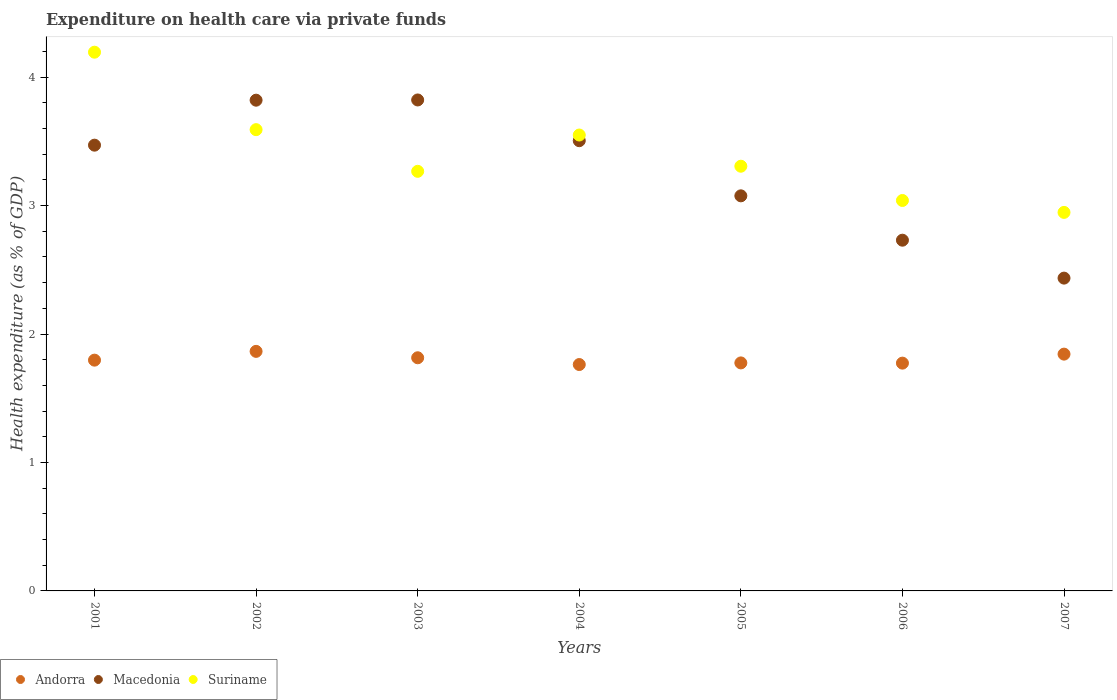What is the expenditure made on health care in Suriname in 2003?
Offer a very short reply. 3.27. Across all years, what is the maximum expenditure made on health care in Macedonia?
Make the answer very short. 3.82. Across all years, what is the minimum expenditure made on health care in Suriname?
Your response must be concise. 2.95. In which year was the expenditure made on health care in Andorra minimum?
Make the answer very short. 2004. What is the total expenditure made on health care in Macedonia in the graph?
Offer a terse response. 22.86. What is the difference between the expenditure made on health care in Suriname in 2001 and that in 2007?
Your response must be concise. 1.25. What is the difference between the expenditure made on health care in Andorra in 2006 and the expenditure made on health care in Suriname in 2004?
Your answer should be very brief. -1.78. What is the average expenditure made on health care in Andorra per year?
Provide a short and direct response. 1.8. In the year 2006, what is the difference between the expenditure made on health care in Suriname and expenditure made on health care in Macedonia?
Ensure brevity in your answer.  0.31. What is the ratio of the expenditure made on health care in Macedonia in 2002 to that in 2006?
Offer a terse response. 1.4. What is the difference between the highest and the second highest expenditure made on health care in Macedonia?
Your answer should be very brief. 0. What is the difference between the highest and the lowest expenditure made on health care in Macedonia?
Offer a very short reply. 1.39. Does the expenditure made on health care in Andorra monotonically increase over the years?
Your answer should be very brief. No. Is the expenditure made on health care in Andorra strictly greater than the expenditure made on health care in Macedonia over the years?
Make the answer very short. No. Is the expenditure made on health care in Suriname strictly less than the expenditure made on health care in Macedonia over the years?
Ensure brevity in your answer.  No. How many dotlines are there?
Offer a very short reply. 3. How many years are there in the graph?
Provide a succinct answer. 7. Are the values on the major ticks of Y-axis written in scientific E-notation?
Offer a very short reply. No. Does the graph contain grids?
Offer a very short reply. No. How many legend labels are there?
Offer a terse response. 3. What is the title of the graph?
Provide a succinct answer. Expenditure on health care via private funds. What is the label or title of the X-axis?
Ensure brevity in your answer.  Years. What is the label or title of the Y-axis?
Your response must be concise. Health expenditure (as % of GDP). What is the Health expenditure (as % of GDP) of Andorra in 2001?
Offer a very short reply. 1.8. What is the Health expenditure (as % of GDP) of Macedonia in 2001?
Provide a short and direct response. 3.47. What is the Health expenditure (as % of GDP) of Suriname in 2001?
Provide a succinct answer. 4.19. What is the Health expenditure (as % of GDP) of Andorra in 2002?
Your answer should be compact. 1.86. What is the Health expenditure (as % of GDP) in Macedonia in 2002?
Provide a succinct answer. 3.82. What is the Health expenditure (as % of GDP) in Suriname in 2002?
Your answer should be very brief. 3.59. What is the Health expenditure (as % of GDP) in Andorra in 2003?
Your answer should be compact. 1.82. What is the Health expenditure (as % of GDP) of Macedonia in 2003?
Offer a very short reply. 3.82. What is the Health expenditure (as % of GDP) of Suriname in 2003?
Offer a very short reply. 3.27. What is the Health expenditure (as % of GDP) in Andorra in 2004?
Ensure brevity in your answer.  1.76. What is the Health expenditure (as % of GDP) in Macedonia in 2004?
Ensure brevity in your answer.  3.5. What is the Health expenditure (as % of GDP) in Suriname in 2004?
Your answer should be compact. 3.55. What is the Health expenditure (as % of GDP) of Andorra in 2005?
Ensure brevity in your answer.  1.77. What is the Health expenditure (as % of GDP) of Macedonia in 2005?
Your response must be concise. 3.08. What is the Health expenditure (as % of GDP) in Suriname in 2005?
Your response must be concise. 3.31. What is the Health expenditure (as % of GDP) in Andorra in 2006?
Your answer should be very brief. 1.77. What is the Health expenditure (as % of GDP) of Macedonia in 2006?
Provide a succinct answer. 2.73. What is the Health expenditure (as % of GDP) of Suriname in 2006?
Provide a short and direct response. 3.04. What is the Health expenditure (as % of GDP) in Andorra in 2007?
Provide a short and direct response. 1.84. What is the Health expenditure (as % of GDP) of Macedonia in 2007?
Your response must be concise. 2.44. What is the Health expenditure (as % of GDP) of Suriname in 2007?
Provide a short and direct response. 2.95. Across all years, what is the maximum Health expenditure (as % of GDP) of Andorra?
Give a very brief answer. 1.86. Across all years, what is the maximum Health expenditure (as % of GDP) of Macedonia?
Keep it short and to the point. 3.82. Across all years, what is the maximum Health expenditure (as % of GDP) in Suriname?
Keep it short and to the point. 4.19. Across all years, what is the minimum Health expenditure (as % of GDP) of Andorra?
Provide a short and direct response. 1.76. Across all years, what is the minimum Health expenditure (as % of GDP) in Macedonia?
Provide a short and direct response. 2.44. Across all years, what is the minimum Health expenditure (as % of GDP) of Suriname?
Your answer should be very brief. 2.95. What is the total Health expenditure (as % of GDP) in Andorra in the graph?
Your answer should be compact. 12.63. What is the total Health expenditure (as % of GDP) of Macedonia in the graph?
Offer a very short reply. 22.86. What is the total Health expenditure (as % of GDP) in Suriname in the graph?
Your answer should be compact. 23.89. What is the difference between the Health expenditure (as % of GDP) in Andorra in 2001 and that in 2002?
Your answer should be very brief. -0.07. What is the difference between the Health expenditure (as % of GDP) of Macedonia in 2001 and that in 2002?
Offer a terse response. -0.35. What is the difference between the Health expenditure (as % of GDP) in Suriname in 2001 and that in 2002?
Give a very brief answer. 0.6. What is the difference between the Health expenditure (as % of GDP) of Andorra in 2001 and that in 2003?
Make the answer very short. -0.02. What is the difference between the Health expenditure (as % of GDP) of Macedonia in 2001 and that in 2003?
Your response must be concise. -0.35. What is the difference between the Health expenditure (as % of GDP) in Suriname in 2001 and that in 2003?
Ensure brevity in your answer.  0.93. What is the difference between the Health expenditure (as % of GDP) in Andorra in 2001 and that in 2004?
Your answer should be very brief. 0.03. What is the difference between the Health expenditure (as % of GDP) of Macedonia in 2001 and that in 2004?
Give a very brief answer. -0.03. What is the difference between the Health expenditure (as % of GDP) in Suriname in 2001 and that in 2004?
Your answer should be compact. 0.64. What is the difference between the Health expenditure (as % of GDP) of Andorra in 2001 and that in 2005?
Ensure brevity in your answer.  0.02. What is the difference between the Health expenditure (as % of GDP) in Macedonia in 2001 and that in 2005?
Make the answer very short. 0.39. What is the difference between the Health expenditure (as % of GDP) of Suriname in 2001 and that in 2005?
Offer a very short reply. 0.89. What is the difference between the Health expenditure (as % of GDP) of Andorra in 2001 and that in 2006?
Offer a terse response. 0.02. What is the difference between the Health expenditure (as % of GDP) of Macedonia in 2001 and that in 2006?
Your answer should be very brief. 0.74. What is the difference between the Health expenditure (as % of GDP) of Suriname in 2001 and that in 2006?
Your response must be concise. 1.15. What is the difference between the Health expenditure (as % of GDP) in Andorra in 2001 and that in 2007?
Keep it short and to the point. -0.05. What is the difference between the Health expenditure (as % of GDP) of Macedonia in 2001 and that in 2007?
Your answer should be very brief. 1.03. What is the difference between the Health expenditure (as % of GDP) of Suriname in 2001 and that in 2007?
Your response must be concise. 1.25. What is the difference between the Health expenditure (as % of GDP) of Andorra in 2002 and that in 2003?
Provide a short and direct response. 0.05. What is the difference between the Health expenditure (as % of GDP) of Macedonia in 2002 and that in 2003?
Your answer should be very brief. -0. What is the difference between the Health expenditure (as % of GDP) in Suriname in 2002 and that in 2003?
Your response must be concise. 0.32. What is the difference between the Health expenditure (as % of GDP) in Andorra in 2002 and that in 2004?
Provide a short and direct response. 0.1. What is the difference between the Health expenditure (as % of GDP) of Macedonia in 2002 and that in 2004?
Offer a very short reply. 0.32. What is the difference between the Health expenditure (as % of GDP) in Suriname in 2002 and that in 2004?
Give a very brief answer. 0.04. What is the difference between the Health expenditure (as % of GDP) of Andorra in 2002 and that in 2005?
Ensure brevity in your answer.  0.09. What is the difference between the Health expenditure (as % of GDP) of Macedonia in 2002 and that in 2005?
Offer a very short reply. 0.74. What is the difference between the Health expenditure (as % of GDP) in Suriname in 2002 and that in 2005?
Give a very brief answer. 0.28. What is the difference between the Health expenditure (as % of GDP) in Andorra in 2002 and that in 2006?
Your response must be concise. 0.09. What is the difference between the Health expenditure (as % of GDP) in Macedonia in 2002 and that in 2006?
Keep it short and to the point. 1.09. What is the difference between the Health expenditure (as % of GDP) in Suriname in 2002 and that in 2006?
Give a very brief answer. 0.55. What is the difference between the Health expenditure (as % of GDP) of Andorra in 2002 and that in 2007?
Give a very brief answer. 0.02. What is the difference between the Health expenditure (as % of GDP) of Macedonia in 2002 and that in 2007?
Make the answer very short. 1.39. What is the difference between the Health expenditure (as % of GDP) in Suriname in 2002 and that in 2007?
Your answer should be compact. 0.64. What is the difference between the Health expenditure (as % of GDP) in Andorra in 2003 and that in 2004?
Your answer should be very brief. 0.05. What is the difference between the Health expenditure (as % of GDP) of Macedonia in 2003 and that in 2004?
Offer a very short reply. 0.32. What is the difference between the Health expenditure (as % of GDP) of Suriname in 2003 and that in 2004?
Make the answer very short. -0.28. What is the difference between the Health expenditure (as % of GDP) in Macedonia in 2003 and that in 2005?
Offer a very short reply. 0.75. What is the difference between the Health expenditure (as % of GDP) in Suriname in 2003 and that in 2005?
Offer a terse response. -0.04. What is the difference between the Health expenditure (as % of GDP) in Andorra in 2003 and that in 2006?
Ensure brevity in your answer.  0.04. What is the difference between the Health expenditure (as % of GDP) in Macedonia in 2003 and that in 2006?
Make the answer very short. 1.09. What is the difference between the Health expenditure (as % of GDP) of Suriname in 2003 and that in 2006?
Ensure brevity in your answer.  0.23. What is the difference between the Health expenditure (as % of GDP) in Andorra in 2003 and that in 2007?
Your answer should be very brief. -0.03. What is the difference between the Health expenditure (as % of GDP) in Macedonia in 2003 and that in 2007?
Keep it short and to the point. 1.39. What is the difference between the Health expenditure (as % of GDP) of Suriname in 2003 and that in 2007?
Provide a short and direct response. 0.32. What is the difference between the Health expenditure (as % of GDP) in Andorra in 2004 and that in 2005?
Provide a succinct answer. -0.01. What is the difference between the Health expenditure (as % of GDP) of Macedonia in 2004 and that in 2005?
Make the answer very short. 0.43. What is the difference between the Health expenditure (as % of GDP) in Suriname in 2004 and that in 2005?
Make the answer very short. 0.24. What is the difference between the Health expenditure (as % of GDP) of Andorra in 2004 and that in 2006?
Your response must be concise. -0.01. What is the difference between the Health expenditure (as % of GDP) of Macedonia in 2004 and that in 2006?
Provide a succinct answer. 0.77. What is the difference between the Health expenditure (as % of GDP) in Suriname in 2004 and that in 2006?
Give a very brief answer. 0.51. What is the difference between the Health expenditure (as % of GDP) in Andorra in 2004 and that in 2007?
Your answer should be compact. -0.08. What is the difference between the Health expenditure (as % of GDP) in Macedonia in 2004 and that in 2007?
Ensure brevity in your answer.  1.07. What is the difference between the Health expenditure (as % of GDP) of Suriname in 2004 and that in 2007?
Offer a terse response. 0.6. What is the difference between the Health expenditure (as % of GDP) in Andorra in 2005 and that in 2006?
Give a very brief answer. 0. What is the difference between the Health expenditure (as % of GDP) of Macedonia in 2005 and that in 2006?
Offer a very short reply. 0.35. What is the difference between the Health expenditure (as % of GDP) in Suriname in 2005 and that in 2006?
Your answer should be compact. 0.27. What is the difference between the Health expenditure (as % of GDP) in Andorra in 2005 and that in 2007?
Make the answer very short. -0.07. What is the difference between the Health expenditure (as % of GDP) of Macedonia in 2005 and that in 2007?
Offer a very short reply. 0.64. What is the difference between the Health expenditure (as % of GDP) in Suriname in 2005 and that in 2007?
Ensure brevity in your answer.  0.36. What is the difference between the Health expenditure (as % of GDP) in Andorra in 2006 and that in 2007?
Ensure brevity in your answer.  -0.07. What is the difference between the Health expenditure (as % of GDP) of Macedonia in 2006 and that in 2007?
Offer a very short reply. 0.3. What is the difference between the Health expenditure (as % of GDP) of Suriname in 2006 and that in 2007?
Offer a terse response. 0.09. What is the difference between the Health expenditure (as % of GDP) in Andorra in 2001 and the Health expenditure (as % of GDP) in Macedonia in 2002?
Provide a short and direct response. -2.02. What is the difference between the Health expenditure (as % of GDP) in Andorra in 2001 and the Health expenditure (as % of GDP) in Suriname in 2002?
Give a very brief answer. -1.79. What is the difference between the Health expenditure (as % of GDP) of Macedonia in 2001 and the Health expenditure (as % of GDP) of Suriname in 2002?
Offer a terse response. -0.12. What is the difference between the Health expenditure (as % of GDP) of Andorra in 2001 and the Health expenditure (as % of GDP) of Macedonia in 2003?
Ensure brevity in your answer.  -2.03. What is the difference between the Health expenditure (as % of GDP) in Andorra in 2001 and the Health expenditure (as % of GDP) in Suriname in 2003?
Give a very brief answer. -1.47. What is the difference between the Health expenditure (as % of GDP) in Macedonia in 2001 and the Health expenditure (as % of GDP) in Suriname in 2003?
Your answer should be compact. 0.2. What is the difference between the Health expenditure (as % of GDP) in Andorra in 2001 and the Health expenditure (as % of GDP) in Macedonia in 2004?
Offer a very short reply. -1.71. What is the difference between the Health expenditure (as % of GDP) in Andorra in 2001 and the Health expenditure (as % of GDP) in Suriname in 2004?
Ensure brevity in your answer.  -1.75. What is the difference between the Health expenditure (as % of GDP) in Macedonia in 2001 and the Health expenditure (as % of GDP) in Suriname in 2004?
Your answer should be compact. -0.08. What is the difference between the Health expenditure (as % of GDP) of Andorra in 2001 and the Health expenditure (as % of GDP) of Macedonia in 2005?
Ensure brevity in your answer.  -1.28. What is the difference between the Health expenditure (as % of GDP) of Andorra in 2001 and the Health expenditure (as % of GDP) of Suriname in 2005?
Offer a very short reply. -1.51. What is the difference between the Health expenditure (as % of GDP) of Macedonia in 2001 and the Health expenditure (as % of GDP) of Suriname in 2005?
Make the answer very short. 0.16. What is the difference between the Health expenditure (as % of GDP) in Andorra in 2001 and the Health expenditure (as % of GDP) in Macedonia in 2006?
Give a very brief answer. -0.93. What is the difference between the Health expenditure (as % of GDP) of Andorra in 2001 and the Health expenditure (as % of GDP) of Suriname in 2006?
Give a very brief answer. -1.24. What is the difference between the Health expenditure (as % of GDP) in Macedonia in 2001 and the Health expenditure (as % of GDP) in Suriname in 2006?
Your answer should be very brief. 0.43. What is the difference between the Health expenditure (as % of GDP) in Andorra in 2001 and the Health expenditure (as % of GDP) in Macedonia in 2007?
Offer a very short reply. -0.64. What is the difference between the Health expenditure (as % of GDP) in Andorra in 2001 and the Health expenditure (as % of GDP) in Suriname in 2007?
Offer a terse response. -1.15. What is the difference between the Health expenditure (as % of GDP) in Macedonia in 2001 and the Health expenditure (as % of GDP) in Suriname in 2007?
Ensure brevity in your answer.  0.52. What is the difference between the Health expenditure (as % of GDP) of Andorra in 2002 and the Health expenditure (as % of GDP) of Macedonia in 2003?
Keep it short and to the point. -1.96. What is the difference between the Health expenditure (as % of GDP) in Andorra in 2002 and the Health expenditure (as % of GDP) in Suriname in 2003?
Offer a terse response. -1.4. What is the difference between the Health expenditure (as % of GDP) of Macedonia in 2002 and the Health expenditure (as % of GDP) of Suriname in 2003?
Your answer should be compact. 0.55. What is the difference between the Health expenditure (as % of GDP) in Andorra in 2002 and the Health expenditure (as % of GDP) in Macedonia in 2004?
Your answer should be compact. -1.64. What is the difference between the Health expenditure (as % of GDP) in Andorra in 2002 and the Health expenditure (as % of GDP) in Suriname in 2004?
Make the answer very short. -1.68. What is the difference between the Health expenditure (as % of GDP) in Macedonia in 2002 and the Health expenditure (as % of GDP) in Suriname in 2004?
Provide a short and direct response. 0.27. What is the difference between the Health expenditure (as % of GDP) in Andorra in 2002 and the Health expenditure (as % of GDP) in Macedonia in 2005?
Offer a terse response. -1.21. What is the difference between the Health expenditure (as % of GDP) of Andorra in 2002 and the Health expenditure (as % of GDP) of Suriname in 2005?
Your response must be concise. -1.44. What is the difference between the Health expenditure (as % of GDP) of Macedonia in 2002 and the Health expenditure (as % of GDP) of Suriname in 2005?
Ensure brevity in your answer.  0.51. What is the difference between the Health expenditure (as % of GDP) in Andorra in 2002 and the Health expenditure (as % of GDP) in Macedonia in 2006?
Keep it short and to the point. -0.87. What is the difference between the Health expenditure (as % of GDP) of Andorra in 2002 and the Health expenditure (as % of GDP) of Suriname in 2006?
Provide a succinct answer. -1.17. What is the difference between the Health expenditure (as % of GDP) of Macedonia in 2002 and the Health expenditure (as % of GDP) of Suriname in 2006?
Your response must be concise. 0.78. What is the difference between the Health expenditure (as % of GDP) in Andorra in 2002 and the Health expenditure (as % of GDP) in Macedonia in 2007?
Your response must be concise. -0.57. What is the difference between the Health expenditure (as % of GDP) in Andorra in 2002 and the Health expenditure (as % of GDP) in Suriname in 2007?
Provide a succinct answer. -1.08. What is the difference between the Health expenditure (as % of GDP) in Macedonia in 2002 and the Health expenditure (as % of GDP) in Suriname in 2007?
Provide a short and direct response. 0.87. What is the difference between the Health expenditure (as % of GDP) of Andorra in 2003 and the Health expenditure (as % of GDP) of Macedonia in 2004?
Provide a succinct answer. -1.69. What is the difference between the Health expenditure (as % of GDP) in Andorra in 2003 and the Health expenditure (as % of GDP) in Suriname in 2004?
Provide a short and direct response. -1.73. What is the difference between the Health expenditure (as % of GDP) of Macedonia in 2003 and the Health expenditure (as % of GDP) of Suriname in 2004?
Your answer should be compact. 0.27. What is the difference between the Health expenditure (as % of GDP) in Andorra in 2003 and the Health expenditure (as % of GDP) in Macedonia in 2005?
Your answer should be very brief. -1.26. What is the difference between the Health expenditure (as % of GDP) of Andorra in 2003 and the Health expenditure (as % of GDP) of Suriname in 2005?
Provide a short and direct response. -1.49. What is the difference between the Health expenditure (as % of GDP) of Macedonia in 2003 and the Health expenditure (as % of GDP) of Suriname in 2005?
Make the answer very short. 0.52. What is the difference between the Health expenditure (as % of GDP) in Andorra in 2003 and the Health expenditure (as % of GDP) in Macedonia in 2006?
Give a very brief answer. -0.92. What is the difference between the Health expenditure (as % of GDP) of Andorra in 2003 and the Health expenditure (as % of GDP) of Suriname in 2006?
Provide a short and direct response. -1.22. What is the difference between the Health expenditure (as % of GDP) of Macedonia in 2003 and the Health expenditure (as % of GDP) of Suriname in 2006?
Keep it short and to the point. 0.78. What is the difference between the Health expenditure (as % of GDP) in Andorra in 2003 and the Health expenditure (as % of GDP) in Macedonia in 2007?
Ensure brevity in your answer.  -0.62. What is the difference between the Health expenditure (as % of GDP) of Andorra in 2003 and the Health expenditure (as % of GDP) of Suriname in 2007?
Your response must be concise. -1.13. What is the difference between the Health expenditure (as % of GDP) in Macedonia in 2003 and the Health expenditure (as % of GDP) in Suriname in 2007?
Your response must be concise. 0.88. What is the difference between the Health expenditure (as % of GDP) of Andorra in 2004 and the Health expenditure (as % of GDP) of Macedonia in 2005?
Offer a very short reply. -1.31. What is the difference between the Health expenditure (as % of GDP) of Andorra in 2004 and the Health expenditure (as % of GDP) of Suriname in 2005?
Your response must be concise. -1.54. What is the difference between the Health expenditure (as % of GDP) in Macedonia in 2004 and the Health expenditure (as % of GDP) in Suriname in 2005?
Give a very brief answer. 0.2. What is the difference between the Health expenditure (as % of GDP) in Andorra in 2004 and the Health expenditure (as % of GDP) in Macedonia in 2006?
Make the answer very short. -0.97. What is the difference between the Health expenditure (as % of GDP) in Andorra in 2004 and the Health expenditure (as % of GDP) in Suriname in 2006?
Your answer should be compact. -1.28. What is the difference between the Health expenditure (as % of GDP) of Macedonia in 2004 and the Health expenditure (as % of GDP) of Suriname in 2006?
Offer a very short reply. 0.47. What is the difference between the Health expenditure (as % of GDP) in Andorra in 2004 and the Health expenditure (as % of GDP) in Macedonia in 2007?
Your answer should be very brief. -0.67. What is the difference between the Health expenditure (as % of GDP) in Andorra in 2004 and the Health expenditure (as % of GDP) in Suriname in 2007?
Your response must be concise. -1.18. What is the difference between the Health expenditure (as % of GDP) of Macedonia in 2004 and the Health expenditure (as % of GDP) of Suriname in 2007?
Your answer should be compact. 0.56. What is the difference between the Health expenditure (as % of GDP) in Andorra in 2005 and the Health expenditure (as % of GDP) in Macedonia in 2006?
Provide a short and direct response. -0.96. What is the difference between the Health expenditure (as % of GDP) in Andorra in 2005 and the Health expenditure (as % of GDP) in Suriname in 2006?
Your answer should be very brief. -1.26. What is the difference between the Health expenditure (as % of GDP) in Macedonia in 2005 and the Health expenditure (as % of GDP) in Suriname in 2006?
Your answer should be compact. 0.04. What is the difference between the Health expenditure (as % of GDP) in Andorra in 2005 and the Health expenditure (as % of GDP) in Macedonia in 2007?
Keep it short and to the point. -0.66. What is the difference between the Health expenditure (as % of GDP) of Andorra in 2005 and the Health expenditure (as % of GDP) of Suriname in 2007?
Ensure brevity in your answer.  -1.17. What is the difference between the Health expenditure (as % of GDP) of Macedonia in 2005 and the Health expenditure (as % of GDP) of Suriname in 2007?
Provide a succinct answer. 0.13. What is the difference between the Health expenditure (as % of GDP) of Andorra in 2006 and the Health expenditure (as % of GDP) of Macedonia in 2007?
Offer a very short reply. -0.66. What is the difference between the Health expenditure (as % of GDP) in Andorra in 2006 and the Health expenditure (as % of GDP) in Suriname in 2007?
Keep it short and to the point. -1.17. What is the difference between the Health expenditure (as % of GDP) of Macedonia in 2006 and the Health expenditure (as % of GDP) of Suriname in 2007?
Make the answer very short. -0.22. What is the average Health expenditure (as % of GDP) in Andorra per year?
Ensure brevity in your answer.  1.8. What is the average Health expenditure (as % of GDP) in Macedonia per year?
Provide a short and direct response. 3.27. What is the average Health expenditure (as % of GDP) in Suriname per year?
Your answer should be compact. 3.41. In the year 2001, what is the difference between the Health expenditure (as % of GDP) in Andorra and Health expenditure (as % of GDP) in Macedonia?
Make the answer very short. -1.67. In the year 2001, what is the difference between the Health expenditure (as % of GDP) in Andorra and Health expenditure (as % of GDP) in Suriname?
Your answer should be very brief. -2.4. In the year 2001, what is the difference between the Health expenditure (as % of GDP) in Macedonia and Health expenditure (as % of GDP) in Suriname?
Your response must be concise. -0.72. In the year 2002, what is the difference between the Health expenditure (as % of GDP) of Andorra and Health expenditure (as % of GDP) of Macedonia?
Provide a succinct answer. -1.96. In the year 2002, what is the difference between the Health expenditure (as % of GDP) of Andorra and Health expenditure (as % of GDP) of Suriname?
Provide a short and direct response. -1.73. In the year 2002, what is the difference between the Health expenditure (as % of GDP) in Macedonia and Health expenditure (as % of GDP) in Suriname?
Give a very brief answer. 0.23. In the year 2003, what is the difference between the Health expenditure (as % of GDP) in Andorra and Health expenditure (as % of GDP) in Macedonia?
Provide a succinct answer. -2.01. In the year 2003, what is the difference between the Health expenditure (as % of GDP) in Andorra and Health expenditure (as % of GDP) in Suriname?
Your answer should be compact. -1.45. In the year 2003, what is the difference between the Health expenditure (as % of GDP) in Macedonia and Health expenditure (as % of GDP) in Suriname?
Provide a succinct answer. 0.56. In the year 2004, what is the difference between the Health expenditure (as % of GDP) in Andorra and Health expenditure (as % of GDP) in Macedonia?
Offer a very short reply. -1.74. In the year 2004, what is the difference between the Health expenditure (as % of GDP) in Andorra and Health expenditure (as % of GDP) in Suriname?
Your answer should be compact. -1.79. In the year 2004, what is the difference between the Health expenditure (as % of GDP) of Macedonia and Health expenditure (as % of GDP) of Suriname?
Your answer should be very brief. -0.04. In the year 2005, what is the difference between the Health expenditure (as % of GDP) of Andorra and Health expenditure (as % of GDP) of Macedonia?
Your answer should be very brief. -1.3. In the year 2005, what is the difference between the Health expenditure (as % of GDP) in Andorra and Health expenditure (as % of GDP) in Suriname?
Provide a succinct answer. -1.53. In the year 2005, what is the difference between the Health expenditure (as % of GDP) of Macedonia and Health expenditure (as % of GDP) of Suriname?
Offer a very short reply. -0.23. In the year 2006, what is the difference between the Health expenditure (as % of GDP) in Andorra and Health expenditure (as % of GDP) in Macedonia?
Give a very brief answer. -0.96. In the year 2006, what is the difference between the Health expenditure (as % of GDP) of Andorra and Health expenditure (as % of GDP) of Suriname?
Ensure brevity in your answer.  -1.27. In the year 2006, what is the difference between the Health expenditure (as % of GDP) of Macedonia and Health expenditure (as % of GDP) of Suriname?
Give a very brief answer. -0.31. In the year 2007, what is the difference between the Health expenditure (as % of GDP) of Andorra and Health expenditure (as % of GDP) of Macedonia?
Offer a terse response. -0.59. In the year 2007, what is the difference between the Health expenditure (as % of GDP) of Andorra and Health expenditure (as % of GDP) of Suriname?
Your answer should be compact. -1.1. In the year 2007, what is the difference between the Health expenditure (as % of GDP) in Macedonia and Health expenditure (as % of GDP) in Suriname?
Offer a very short reply. -0.51. What is the ratio of the Health expenditure (as % of GDP) in Andorra in 2001 to that in 2002?
Your answer should be very brief. 0.96. What is the ratio of the Health expenditure (as % of GDP) in Macedonia in 2001 to that in 2002?
Give a very brief answer. 0.91. What is the ratio of the Health expenditure (as % of GDP) in Suriname in 2001 to that in 2002?
Make the answer very short. 1.17. What is the ratio of the Health expenditure (as % of GDP) of Macedonia in 2001 to that in 2003?
Your response must be concise. 0.91. What is the ratio of the Health expenditure (as % of GDP) in Suriname in 2001 to that in 2003?
Ensure brevity in your answer.  1.28. What is the ratio of the Health expenditure (as % of GDP) of Andorra in 2001 to that in 2004?
Your response must be concise. 1.02. What is the ratio of the Health expenditure (as % of GDP) in Suriname in 2001 to that in 2004?
Your answer should be compact. 1.18. What is the ratio of the Health expenditure (as % of GDP) in Andorra in 2001 to that in 2005?
Your answer should be compact. 1.01. What is the ratio of the Health expenditure (as % of GDP) in Macedonia in 2001 to that in 2005?
Make the answer very short. 1.13. What is the ratio of the Health expenditure (as % of GDP) of Suriname in 2001 to that in 2005?
Provide a short and direct response. 1.27. What is the ratio of the Health expenditure (as % of GDP) in Andorra in 2001 to that in 2006?
Ensure brevity in your answer.  1.01. What is the ratio of the Health expenditure (as % of GDP) in Macedonia in 2001 to that in 2006?
Your response must be concise. 1.27. What is the ratio of the Health expenditure (as % of GDP) in Suriname in 2001 to that in 2006?
Your response must be concise. 1.38. What is the ratio of the Health expenditure (as % of GDP) in Andorra in 2001 to that in 2007?
Make the answer very short. 0.97. What is the ratio of the Health expenditure (as % of GDP) of Macedonia in 2001 to that in 2007?
Your response must be concise. 1.43. What is the ratio of the Health expenditure (as % of GDP) in Suriname in 2001 to that in 2007?
Give a very brief answer. 1.42. What is the ratio of the Health expenditure (as % of GDP) of Andorra in 2002 to that in 2003?
Provide a succinct answer. 1.03. What is the ratio of the Health expenditure (as % of GDP) in Suriname in 2002 to that in 2003?
Your answer should be very brief. 1.1. What is the ratio of the Health expenditure (as % of GDP) in Andorra in 2002 to that in 2004?
Make the answer very short. 1.06. What is the ratio of the Health expenditure (as % of GDP) of Macedonia in 2002 to that in 2004?
Provide a short and direct response. 1.09. What is the ratio of the Health expenditure (as % of GDP) in Suriname in 2002 to that in 2004?
Your response must be concise. 1.01. What is the ratio of the Health expenditure (as % of GDP) of Andorra in 2002 to that in 2005?
Your answer should be very brief. 1.05. What is the ratio of the Health expenditure (as % of GDP) of Macedonia in 2002 to that in 2005?
Ensure brevity in your answer.  1.24. What is the ratio of the Health expenditure (as % of GDP) of Suriname in 2002 to that in 2005?
Your response must be concise. 1.09. What is the ratio of the Health expenditure (as % of GDP) in Andorra in 2002 to that in 2006?
Your answer should be compact. 1.05. What is the ratio of the Health expenditure (as % of GDP) in Macedonia in 2002 to that in 2006?
Give a very brief answer. 1.4. What is the ratio of the Health expenditure (as % of GDP) of Suriname in 2002 to that in 2006?
Your answer should be very brief. 1.18. What is the ratio of the Health expenditure (as % of GDP) in Andorra in 2002 to that in 2007?
Provide a short and direct response. 1.01. What is the ratio of the Health expenditure (as % of GDP) of Macedonia in 2002 to that in 2007?
Your answer should be very brief. 1.57. What is the ratio of the Health expenditure (as % of GDP) of Suriname in 2002 to that in 2007?
Your answer should be compact. 1.22. What is the ratio of the Health expenditure (as % of GDP) in Andorra in 2003 to that in 2004?
Provide a short and direct response. 1.03. What is the ratio of the Health expenditure (as % of GDP) of Macedonia in 2003 to that in 2004?
Offer a terse response. 1.09. What is the ratio of the Health expenditure (as % of GDP) in Suriname in 2003 to that in 2004?
Provide a short and direct response. 0.92. What is the ratio of the Health expenditure (as % of GDP) of Andorra in 2003 to that in 2005?
Offer a very short reply. 1.02. What is the ratio of the Health expenditure (as % of GDP) in Macedonia in 2003 to that in 2005?
Offer a very short reply. 1.24. What is the ratio of the Health expenditure (as % of GDP) of Andorra in 2003 to that in 2006?
Ensure brevity in your answer.  1.02. What is the ratio of the Health expenditure (as % of GDP) in Macedonia in 2003 to that in 2006?
Your answer should be compact. 1.4. What is the ratio of the Health expenditure (as % of GDP) in Suriname in 2003 to that in 2006?
Give a very brief answer. 1.07. What is the ratio of the Health expenditure (as % of GDP) of Andorra in 2003 to that in 2007?
Ensure brevity in your answer.  0.98. What is the ratio of the Health expenditure (as % of GDP) in Macedonia in 2003 to that in 2007?
Your response must be concise. 1.57. What is the ratio of the Health expenditure (as % of GDP) in Suriname in 2003 to that in 2007?
Provide a short and direct response. 1.11. What is the ratio of the Health expenditure (as % of GDP) of Macedonia in 2004 to that in 2005?
Offer a very short reply. 1.14. What is the ratio of the Health expenditure (as % of GDP) of Suriname in 2004 to that in 2005?
Provide a succinct answer. 1.07. What is the ratio of the Health expenditure (as % of GDP) in Andorra in 2004 to that in 2006?
Offer a very short reply. 0.99. What is the ratio of the Health expenditure (as % of GDP) of Macedonia in 2004 to that in 2006?
Your response must be concise. 1.28. What is the ratio of the Health expenditure (as % of GDP) in Suriname in 2004 to that in 2006?
Offer a terse response. 1.17. What is the ratio of the Health expenditure (as % of GDP) in Andorra in 2004 to that in 2007?
Keep it short and to the point. 0.96. What is the ratio of the Health expenditure (as % of GDP) in Macedonia in 2004 to that in 2007?
Provide a short and direct response. 1.44. What is the ratio of the Health expenditure (as % of GDP) of Suriname in 2004 to that in 2007?
Provide a succinct answer. 1.2. What is the ratio of the Health expenditure (as % of GDP) in Andorra in 2005 to that in 2006?
Keep it short and to the point. 1. What is the ratio of the Health expenditure (as % of GDP) in Macedonia in 2005 to that in 2006?
Offer a very short reply. 1.13. What is the ratio of the Health expenditure (as % of GDP) of Suriname in 2005 to that in 2006?
Offer a very short reply. 1.09. What is the ratio of the Health expenditure (as % of GDP) in Andorra in 2005 to that in 2007?
Your response must be concise. 0.96. What is the ratio of the Health expenditure (as % of GDP) of Macedonia in 2005 to that in 2007?
Your answer should be very brief. 1.26. What is the ratio of the Health expenditure (as % of GDP) of Suriname in 2005 to that in 2007?
Ensure brevity in your answer.  1.12. What is the ratio of the Health expenditure (as % of GDP) of Macedonia in 2006 to that in 2007?
Provide a succinct answer. 1.12. What is the ratio of the Health expenditure (as % of GDP) in Suriname in 2006 to that in 2007?
Ensure brevity in your answer.  1.03. What is the difference between the highest and the second highest Health expenditure (as % of GDP) in Andorra?
Your answer should be compact. 0.02. What is the difference between the highest and the second highest Health expenditure (as % of GDP) of Macedonia?
Make the answer very short. 0. What is the difference between the highest and the second highest Health expenditure (as % of GDP) in Suriname?
Your answer should be compact. 0.6. What is the difference between the highest and the lowest Health expenditure (as % of GDP) of Andorra?
Your response must be concise. 0.1. What is the difference between the highest and the lowest Health expenditure (as % of GDP) in Macedonia?
Your answer should be very brief. 1.39. What is the difference between the highest and the lowest Health expenditure (as % of GDP) in Suriname?
Offer a terse response. 1.25. 